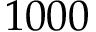<formula> <loc_0><loc_0><loc_500><loc_500>1 0 0 0</formula> 